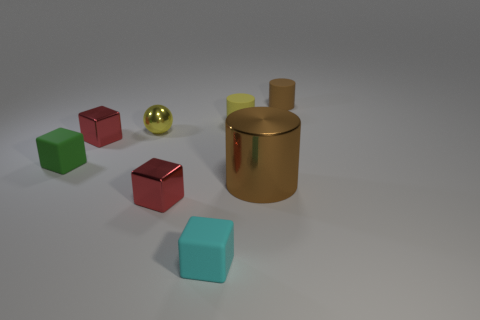There is a small rubber thing on the left side of the tiny red object behind the tiny green cube; what is its shape?
Keep it short and to the point. Cube. Are there more tiny spheres that are on the left side of the small green block than big red rubber cylinders?
Provide a short and direct response. No. Do the rubber object that is left of the cyan matte block and the small brown thing have the same shape?
Provide a succinct answer. No. Are there any green objects that have the same shape as the tiny yellow rubber thing?
Ensure brevity in your answer.  No. What number of objects are yellow objects on the left side of the yellow matte object or tiny objects?
Your answer should be compact. 7. Is the number of objects greater than the number of large yellow objects?
Provide a succinct answer. Yes. Is there a metallic block that has the same size as the yellow cylinder?
Keep it short and to the point. Yes. How many objects are either small matte things right of the yellow rubber cylinder or small shiny blocks in front of the green matte block?
Make the answer very short. 2. There is a rubber block that is to the left of the small red shiny thing that is left of the tiny ball; what is its color?
Give a very brief answer. Green. What is the color of the small sphere that is made of the same material as the large brown cylinder?
Make the answer very short. Yellow. 